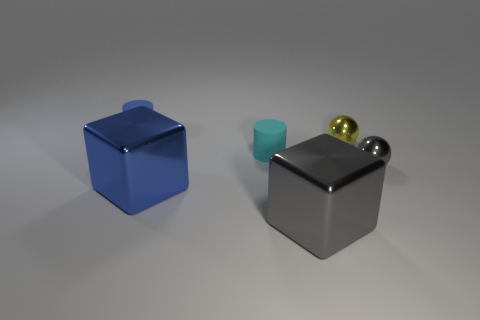Add 4 big red blocks. How many objects exist? 10 Subtract all cubes. How many objects are left? 4 Subtract 2 cylinders. How many cylinders are left? 0 Add 3 large blue blocks. How many large blue blocks exist? 4 Subtract 0 green spheres. How many objects are left? 6 Subtract all gray cylinders. Subtract all green cubes. How many cylinders are left? 2 Subtract all brown spheres. How many gray blocks are left? 1 Subtract all gray metallic spheres. Subtract all big blue metal blocks. How many objects are left? 4 Add 6 tiny cyan rubber cylinders. How many tiny cyan rubber cylinders are left? 7 